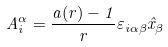Convert formula to latex. <formula><loc_0><loc_0><loc_500><loc_500>A _ { i } ^ { \alpha } = \frac { a ( r ) - 1 } { r } \varepsilon _ { i \alpha \beta } \hat { x } _ { \beta }</formula> 